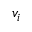<formula> <loc_0><loc_0><loc_500><loc_500>v _ { i }</formula> 